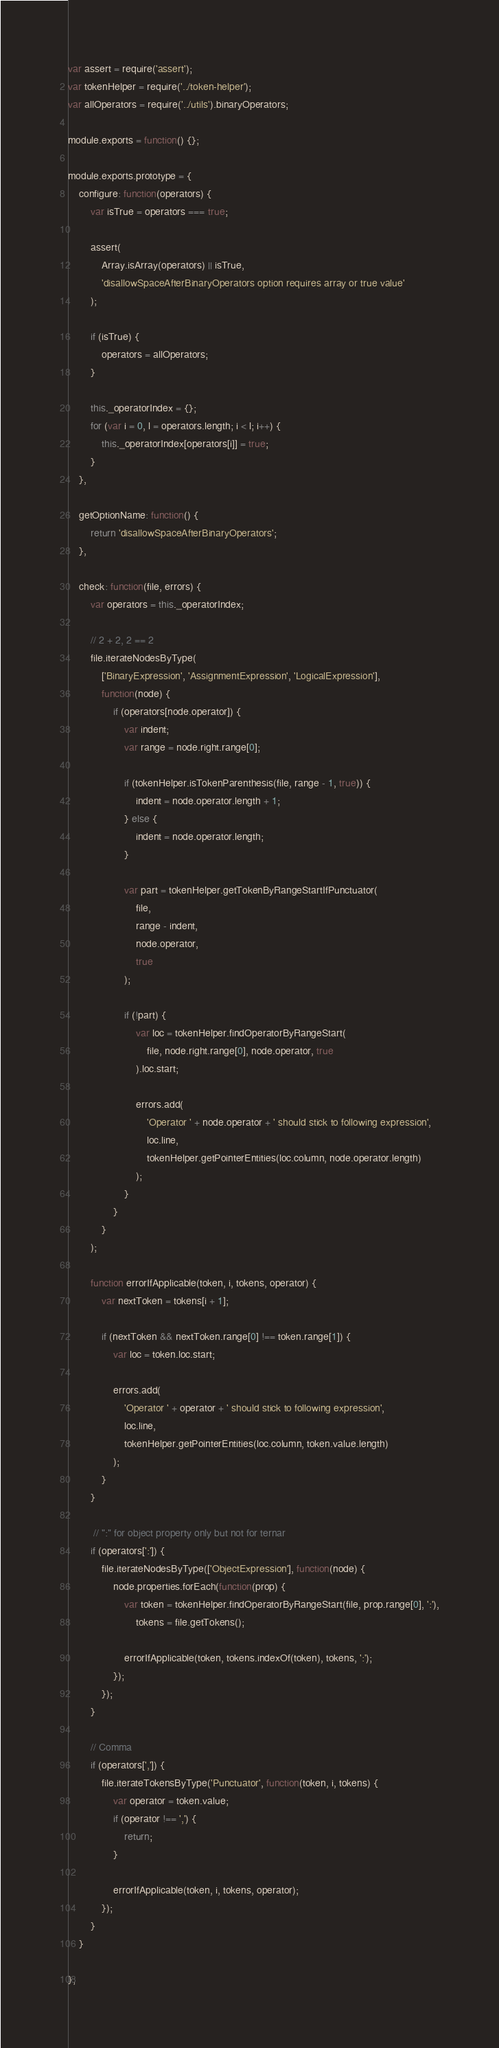<code> <loc_0><loc_0><loc_500><loc_500><_JavaScript_>var assert = require('assert');
var tokenHelper = require('../token-helper');
var allOperators = require('../utils').binaryOperators;

module.exports = function() {};

module.exports.prototype = {
    configure: function(operators) {
        var isTrue = operators === true;

        assert(
            Array.isArray(operators) || isTrue,
            'disallowSpaceAfterBinaryOperators option requires array or true value'
        );

        if (isTrue) {
            operators = allOperators;
        }

        this._operatorIndex = {};
        for (var i = 0, l = operators.length; i < l; i++) {
            this._operatorIndex[operators[i]] = true;
        }
    },

    getOptionName: function() {
        return 'disallowSpaceAfterBinaryOperators';
    },

    check: function(file, errors) {
        var operators = this._operatorIndex;

        // 2 + 2, 2 == 2
        file.iterateNodesByType(
            ['BinaryExpression', 'AssignmentExpression', 'LogicalExpression'],
            function(node) {
                if (operators[node.operator]) {
                    var indent;
                    var range = node.right.range[0];

                    if (tokenHelper.isTokenParenthesis(file, range - 1, true)) {
                        indent = node.operator.length + 1;
                    } else {
                        indent = node.operator.length;
                    }

                    var part = tokenHelper.getTokenByRangeStartIfPunctuator(
                        file,
                        range - indent,
                        node.operator,
                        true
                    );

                    if (!part) {
                        var loc = tokenHelper.findOperatorByRangeStart(
                            file, node.right.range[0], node.operator, true
                        ).loc.start;

                        errors.add(
                            'Operator ' + node.operator + ' should stick to following expression',
                            loc.line,
                            tokenHelper.getPointerEntities(loc.column, node.operator.length)
                        );
                    }
                }
            }
        );

        function errorIfApplicable(token, i, tokens, operator) {
            var nextToken = tokens[i + 1];

            if (nextToken && nextToken.range[0] !== token.range[1]) {
                var loc = token.loc.start;

                errors.add(
                    'Operator ' + operator + ' should stick to following expression',
                    loc.line,
                    tokenHelper.getPointerEntities(loc.column, token.value.length)
                );
            }
        }

         // ":" for object property only but not for ternar
        if (operators[':']) {
            file.iterateNodesByType(['ObjectExpression'], function(node) {
                node.properties.forEach(function(prop) {
                    var token = tokenHelper.findOperatorByRangeStart(file, prop.range[0], ':'),
                        tokens = file.getTokens();

                    errorIfApplicable(token, tokens.indexOf(token), tokens, ':');
                });
            });
        }

        // Comma
        if (operators[',']) {
            file.iterateTokensByType('Punctuator', function(token, i, tokens) {
                var operator = token.value;
                if (operator !== ',') {
                    return;
                }

                errorIfApplicable(token, i, tokens, operator);
            });
        }
    }

};
</code> 